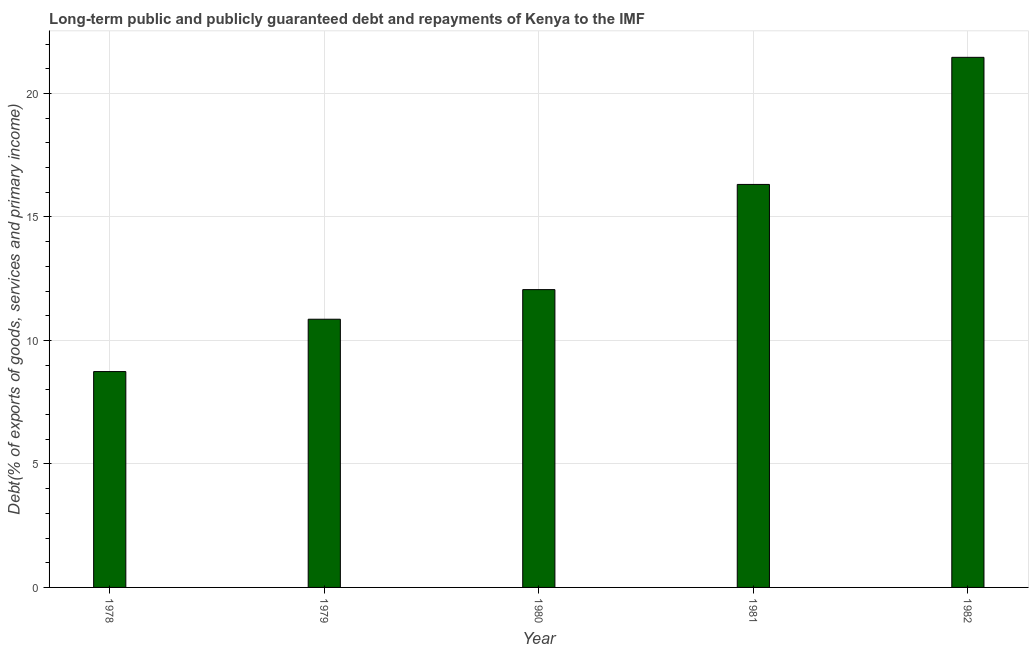Does the graph contain any zero values?
Offer a very short reply. No. Does the graph contain grids?
Provide a succinct answer. Yes. What is the title of the graph?
Offer a very short reply. Long-term public and publicly guaranteed debt and repayments of Kenya to the IMF. What is the label or title of the X-axis?
Make the answer very short. Year. What is the label or title of the Y-axis?
Offer a terse response. Debt(% of exports of goods, services and primary income). What is the debt service in 1982?
Provide a short and direct response. 21.46. Across all years, what is the maximum debt service?
Your response must be concise. 21.46. Across all years, what is the minimum debt service?
Make the answer very short. 8.74. In which year was the debt service maximum?
Keep it short and to the point. 1982. In which year was the debt service minimum?
Your answer should be very brief. 1978. What is the sum of the debt service?
Provide a succinct answer. 69.44. What is the difference between the debt service in 1981 and 1982?
Offer a terse response. -5.15. What is the average debt service per year?
Keep it short and to the point. 13.89. What is the median debt service?
Ensure brevity in your answer.  12.06. Do a majority of the years between 1978 and 1981 (inclusive) have debt service greater than 11 %?
Your answer should be very brief. No. What is the ratio of the debt service in 1978 to that in 1981?
Offer a terse response. 0.54. Is the debt service in 1979 less than that in 1981?
Ensure brevity in your answer.  Yes. What is the difference between the highest and the second highest debt service?
Offer a terse response. 5.15. Is the sum of the debt service in 1980 and 1981 greater than the maximum debt service across all years?
Provide a succinct answer. Yes. What is the difference between the highest and the lowest debt service?
Make the answer very short. 12.72. How many bars are there?
Provide a succinct answer. 5. Are all the bars in the graph horizontal?
Give a very brief answer. No. What is the difference between two consecutive major ticks on the Y-axis?
Your answer should be very brief. 5. What is the Debt(% of exports of goods, services and primary income) in 1978?
Keep it short and to the point. 8.74. What is the Debt(% of exports of goods, services and primary income) in 1979?
Make the answer very short. 10.86. What is the Debt(% of exports of goods, services and primary income) of 1980?
Provide a short and direct response. 12.06. What is the Debt(% of exports of goods, services and primary income) of 1981?
Your response must be concise. 16.32. What is the Debt(% of exports of goods, services and primary income) in 1982?
Offer a very short reply. 21.46. What is the difference between the Debt(% of exports of goods, services and primary income) in 1978 and 1979?
Your answer should be very brief. -2.12. What is the difference between the Debt(% of exports of goods, services and primary income) in 1978 and 1980?
Keep it short and to the point. -3.32. What is the difference between the Debt(% of exports of goods, services and primary income) in 1978 and 1981?
Give a very brief answer. -7.58. What is the difference between the Debt(% of exports of goods, services and primary income) in 1978 and 1982?
Your answer should be very brief. -12.72. What is the difference between the Debt(% of exports of goods, services and primary income) in 1979 and 1980?
Ensure brevity in your answer.  -1.2. What is the difference between the Debt(% of exports of goods, services and primary income) in 1979 and 1981?
Ensure brevity in your answer.  -5.46. What is the difference between the Debt(% of exports of goods, services and primary income) in 1979 and 1982?
Offer a very short reply. -10.6. What is the difference between the Debt(% of exports of goods, services and primary income) in 1980 and 1981?
Provide a succinct answer. -4.26. What is the difference between the Debt(% of exports of goods, services and primary income) in 1980 and 1982?
Your response must be concise. -9.41. What is the difference between the Debt(% of exports of goods, services and primary income) in 1981 and 1982?
Keep it short and to the point. -5.15. What is the ratio of the Debt(% of exports of goods, services and primary income) in 1978 to that in 1979?
Provide a succinct answer. 0.81. What is the ratio of the Debt(% of exports of goods, services and primary income) in 1978 to that in 1980?
Provide a succinct answer. 0.72. What is the ratio of the Debt(% of exports of goods, services and primary income) in 1978 to that in 1981?
Make the answer very short. 0.54. What is the ratio of the Debt(% of exports of goods, services and primary income) in 1978 to that in 1982?
Give a very brief answer. 0.41. What is the ratio of the Debt(% of exports of goods, services and primary income) in 1979 to that in 1980?
Your answer should be compact. 0.9. What is the ratio of the Debt(% of exports of goods, services and primary income) in 1979 to that in 1981?
Provide a short and direct response. 0.67. What is the ratio of the Debt(% of exports of goods, services and primary income) in 1979 to that in 1982?
Ensure brevity in your answer.  0.51. What is the ratio of the Debt(% of exports of goods, services and primary income) in 1980 to that in 1981?
Ensure brevity in your answer.  0.74. What is the ratio of the Debt(% of exports of goods, services and primary income) in 1980 to that in 1982?
Give a very brief answer. 0.56. What is the ratio of the Debt(% of exports of goods, services and primary income) in 1981 to that in 1982?
Your response must be concise. 0.76. 